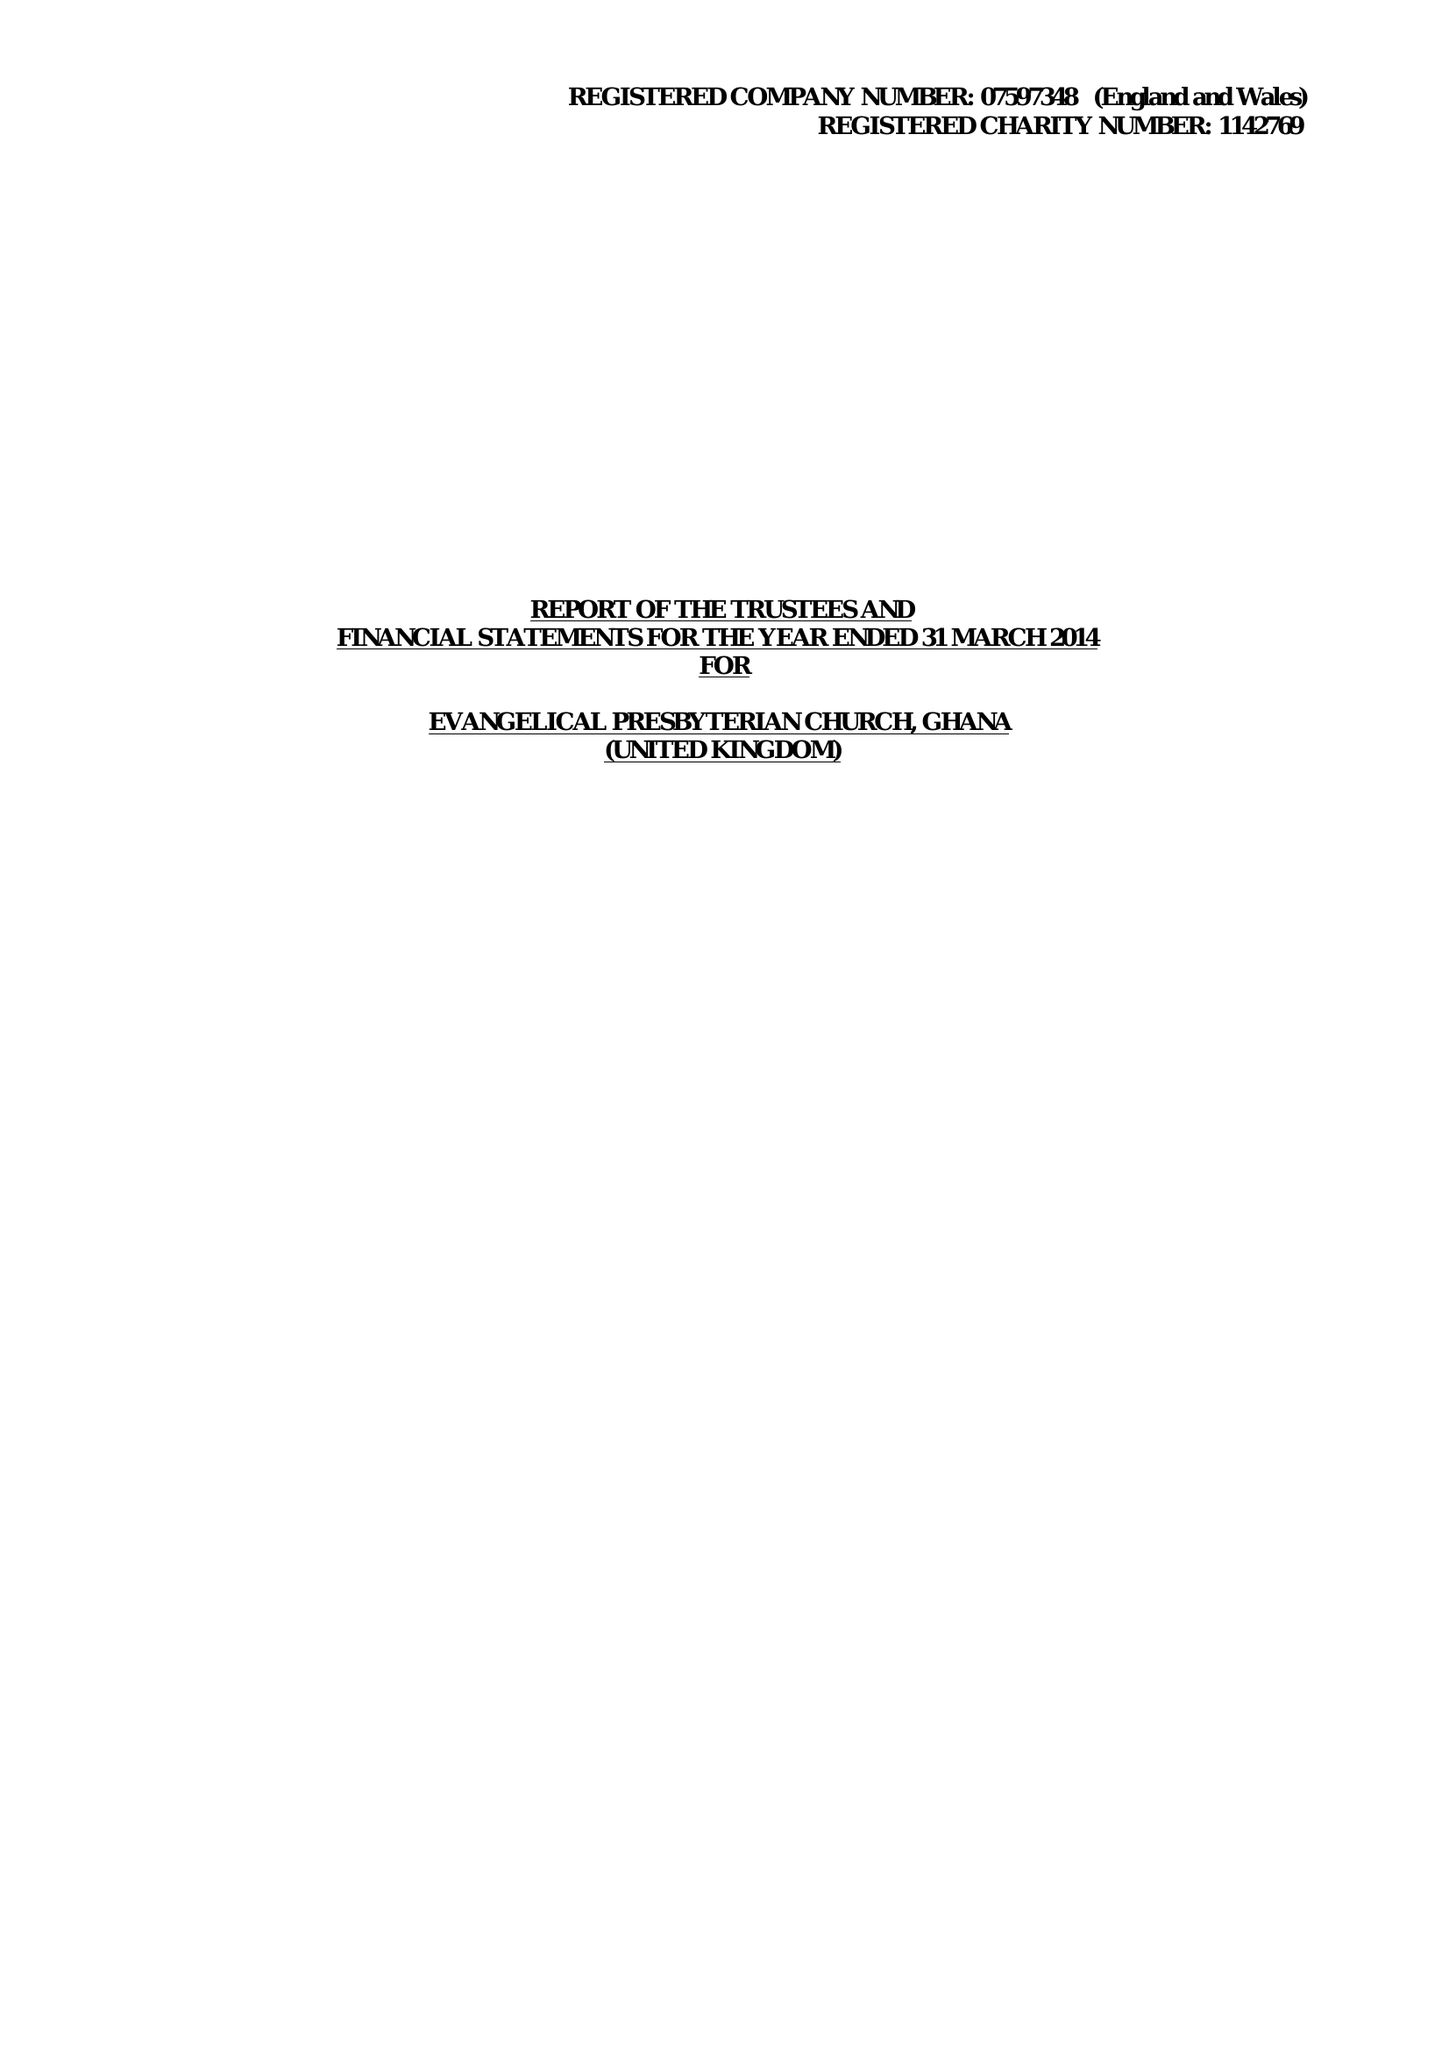What is the value for the address__post_town?
Answer the question using a single word or phrase. FELTHAM 